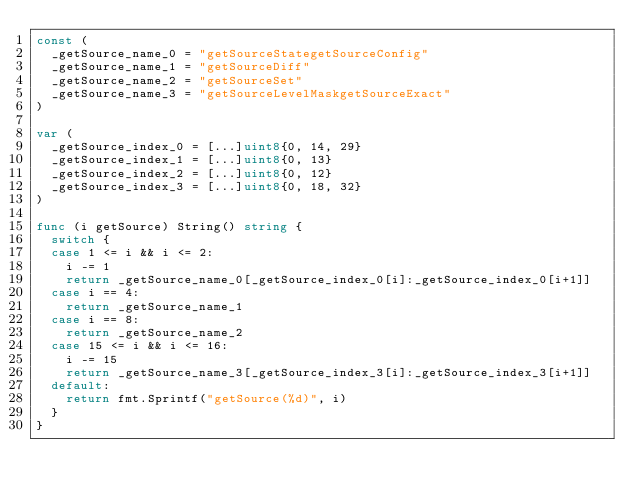Convert code to text. <code><loc_0><loc_0><loc_500><loc_500><_Go_>const (
	_getSource_name_0 = "getSourceStategetSourceConfig"
	_getSource_name_1 = "getSourceDiff"
	_getSource_name_2 = "getSourceSet"
	_getSource_name_3 = "getSourceLevelMaskgetSourceExact"
)

var (
	_getSource_index_0 = [...]uint8{0, 14, 29}
	_getSource_index_1 = [...]uint8{0, 13}
	_getSource_index_2 = [...]uint8{0, 12}
	_getSource_index_3 = [...]uint8{0, 18, 32}
)

func (i getSource) String() string {
	switch {
	case 1 <= i && i <= 2:
		i -= 1
		return _getSource_name_0[_getSource_index_0[i]:_getSource_index_0[i+1]]
	case i == 4:
		return _getSource_name_1
	case i == 8:
		return _getSource_name_2
	case 15 <= i && i <= 16:
		i -= 15
		return _getSource_name_3[_getSource_index_3[i]:_getSource_index_3[i+1]]
	default:
		return fmt.Sprintf("getSource(%d)", i)
	}
}
</code> 